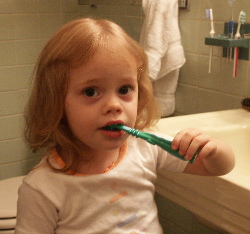<image>What animal is on the end of the toothbrush? It is unclear what animal is on the end of the toothbrush. What animal is on the end of the toothbrush? I don't know what animal is on the end of the toothbrush. It can be a human, a girl, a dinosaur, an alligator, a fish, or something else. 